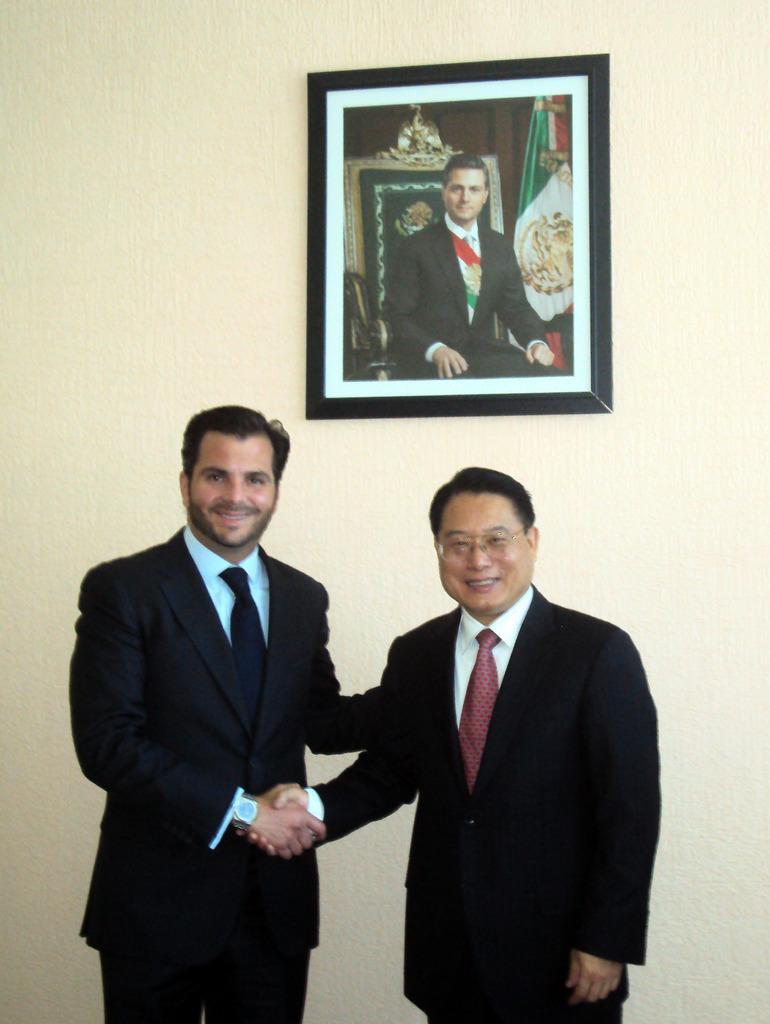Can you describe this image briefly? In the center of the image there are two persons shaking hands. In the background of the image there is a wall on which there is a photo frame. 